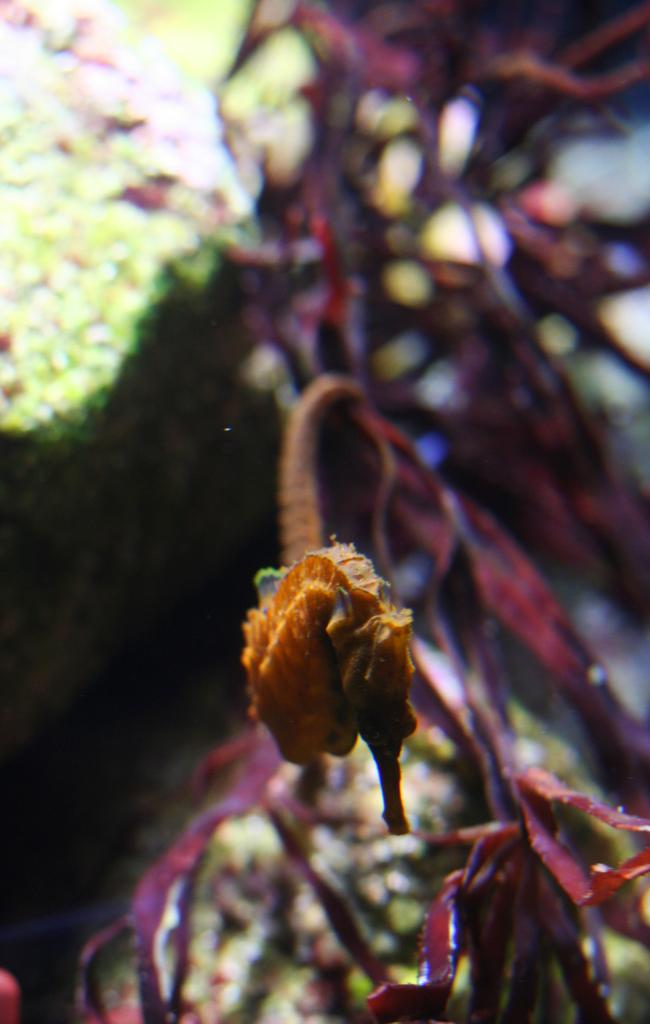What is the main subject in the foreground of the image? There is a seahorse in the foreground of the image. Where is the seahorse located? The seahorse is underwater. What can be seen in the background of the image? There are sea plants in the background of the image. What type of bread can be seen floating near the seahorse in the image? There is no bread present in the image; it features a seahorse underwater with sea plants in the background. 